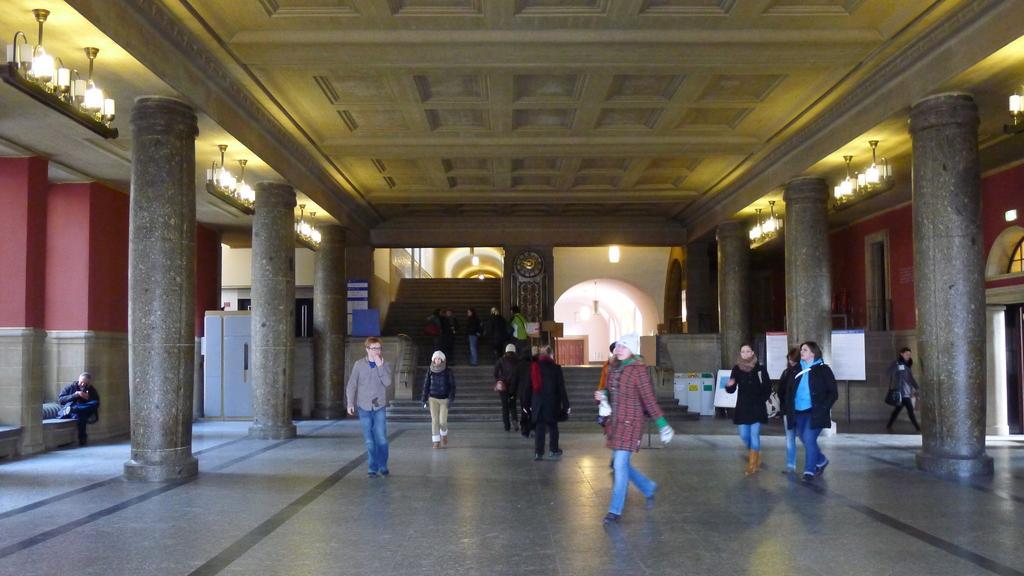Please provide a concise description of this image. In this image there are people walking on the floor. Behind them there are a few other people standing on the stairs. There are pillars. There is a wall. On top of the image there are lights. There are boards. In the center of the image there is a clock. 